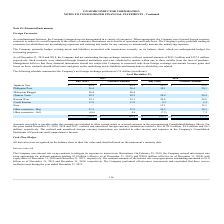According to On Semiconductor's financial document, What was the net notional amount of net outstanding foreign exchange contracts as of December 31, 2019? According to the financial document, $183.3 million. The relevant text states: "gn exchange contracts with net notional amounts of $183.3 million and $157.3 million, respectively. Such contracts were obtained through financial institutions and we..." Also, What was the net notional amount of net outstanding foreign exchange contracts as of December 31, 2018? According to the financial document, $157.3 million. The relevant text states: "ts with net notional amounts of $183.3 million and $157.3 million, respectively. Such contracts were obtained through financial institutions and were scheduled to ma..." Also, How much was the loss of realized and unrealized foreign currency transactions for the years ended December 31, 2019, 2018 and 2017 respectively? The document contains multiple relevant values: $5.0 million, $8.0 million, $6.3 million. From the document: "s totaled a loss of $5.0 million, $8.0 million and $6.3 million, respectively. The realized and unrealized foreign currency transactions are included ..." Also, can you calculate: What is the change in the Japanese Yen Buy position from December 31, 2018 to 2019? Based on the calculation: 49.8-29.9, the result is 19.9 (in millions). This is based on the information: "Japanese Yen $ 49.8 $ 49.8 $ 29.9 $ 29.9 Japanese Yen $ 49.8 $ 49.8 $ 29.9 $ 29.9..." The key data points involved are: 29.9, 49.8. Also, can you calculate: What is the change in Philippine Peso Buy position from year ended December 31, 2018 to 2019? Based on the calculation: 36.4-30.1, the result is 6.3 (in millions). This is based on the information: "Philippine Peso 36.4 36.4 30.1 30.1 Philippine Peso 36.4 36.4 30.1 30.1..." The key data points involved are: 30.1, 36.4. Also, can you calculate: What is the average Japanese Yen Buy position for December 31, 2018 and 2019? To answer this question, I need to perform calculations using the financial data. The calculation is: (49.8+29.9) / 2, which equals 39.85 (in millions). This is based on the information: "Japanese Yen $ 49.8 $ 49.8 $ 29.9 $ 29.9 Japanese Yen $ 49.8 $ 49.8 $ 29.9 $ 29.9..." The key data points involved are: 29.9, 49.8. 